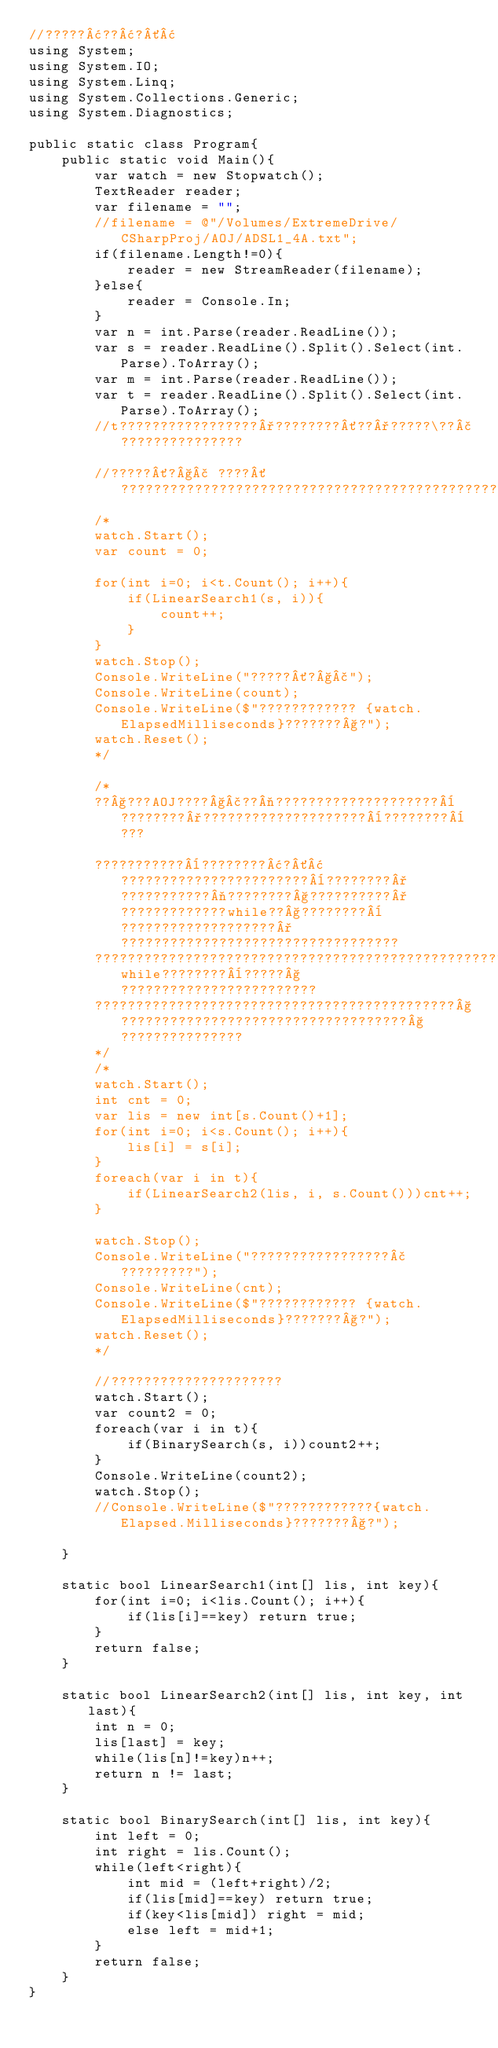Convert code to text. <code><loc_0><loc_0><loc_500><loc_500><_C#_>//?????¢??¢?´¢
using System;
using System.IO;
using System.Linq;
using System.Collections.Generic;
using System.Diagnostics;

public static class Program{
    public static void Main(){
        var watch = new Stopwatch();
        TextReader reader;
        var filename = "";
        //filename = @"/Volumes/ExtremeDrive/CSharpProj/AOJ/ADSL1_4A.txt";
        if(filename.Length!=0){
            reader = new StreamReader(filename);
        }else{
            reader = Console.In;
        }
        var n = int.Parse(reader.ReadLine());
        var s = reader.ReadLine().Split().Select(int.Parse).ToArray();
        var m = int.Parse(reader.ReadLine());
        var t = reader.ReadLine().Split().Select(int.Parse).ToArray();
        //t?????????????????°????????´??°?????\??£???????????????
        
        //?????´?§£ ????´?????????????????????????????????????????????????
        /*
        watch.Start();
        var count = 0;
        
        for(int i=0; i<t.Count(); i++){
            if(LinearSearch1(s, i)){
                count++;
            }
        }
        watch.Stop();
        Console.WriteLine("?????´?§£");
        Console.WriteLine(count);
        Console.WriteLine($"???????????? {watch.ElapsedMilliseconds}???????§?");
        watch.Reset();
        */

        /*
        ??§???AOJ????§£??¬????????????????????¨????????°????????????????????¨????????¨???
        
        ???????????¨????????¢?´¢???????????????????????¨????????°???????????¬????????§??????????°?????????????while??§????????¨???????????????????°??????????????????????????????????
        ??????????????????????????????????????????????????????????????????????????????while????????¨?????§????????????????????????
        ????????????????????????????????????????????§???????????????????????????????????§???????????????
        */
        /*
        watch.Start();
        int cnt = 0;
        var lis = new int[s.Count()+1];
        for(int i=0; i<s.Count(); i++){
            lis[i] = s[i];
        }
        foreach(var i in t){
            if(LinearSearch2(lis, i, s.Count()))cnt++;
        }

        watch.Stop();
        Console.WriteLine("?????????????????£?????????");
        Console.WriteLine(cnt);
        Console.WriteLine($"???????????? {watch.ElapsedMilliseconds}???????§?");
        watch.Reset();
        */

        //?????????????????????
        watch.Start();
        var count2 = 0;
        foreach(var i in t){
            if(BinarySearch(s, i))count2++;
        }
        Console.WriteLine(count2);
        watch.Stop();
        //Console.WriteLine($"????????????{watch.Elapsed.Milliseconds}???????§?");

    }

    static bool LinearSearch1(int[] lis, int key){
        for(int i=0; i<lis.Count(); i++){
            if(lis[i]==key) return true;
        }
        return false;
    }

    static bool LinearSearch2(int[] lis, int key, int last){
        int n = 0;
        lis[last] = key;
        while(lis[n]!=key)n++;
        return n != last;
    }

    static bool BinarySearch(int[] lis, int key){
        int left = 0;
        int right = lis.Count();
        while(left<right){
            int mid = (left+right)/2;
            if(lis[mid]==key) return true;
            if(key<lis[mid]) right = mid;
            else left = mid+1;
        }
        return false;
    }
}</code> 